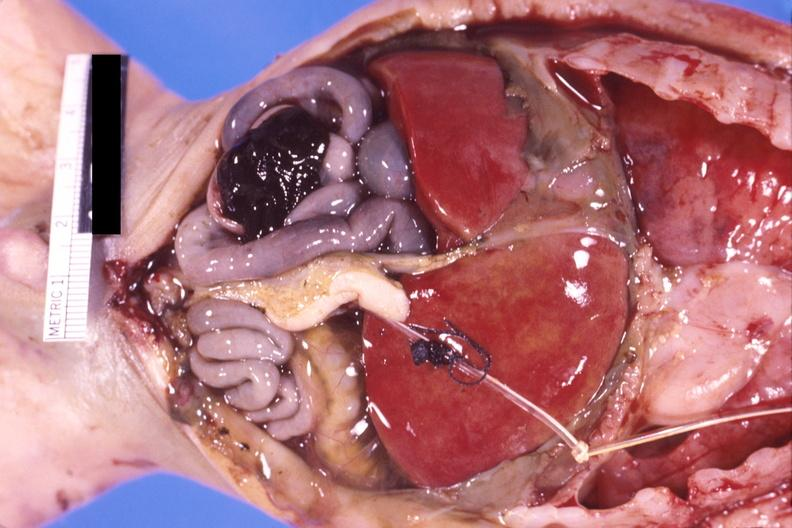does this image show pneumotosis intestinalis with rupture and hemorrhage in a patient with hyaline membrane disease?
Answer the question using a single word or phrase. Yes 